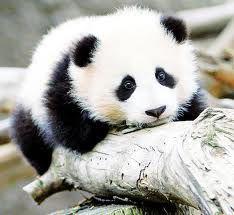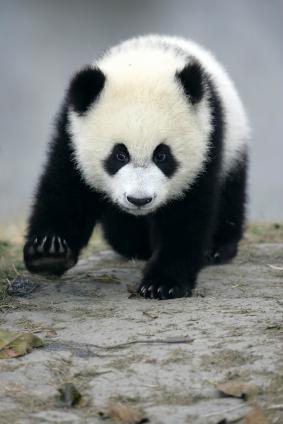The first image is the image on the left, the second image is the image on the right. For the images shown, is this caption "An image shows one camera-facing panda in a grassy area, standing with all four paws on a surface." true? Answer yes or no. No. The first image is the image on the left, the second image is the image on the right. Given the left and right images, does the statement "The panda in the image on the right has its arm around a branch." hold true? Answer yes or no. No. 